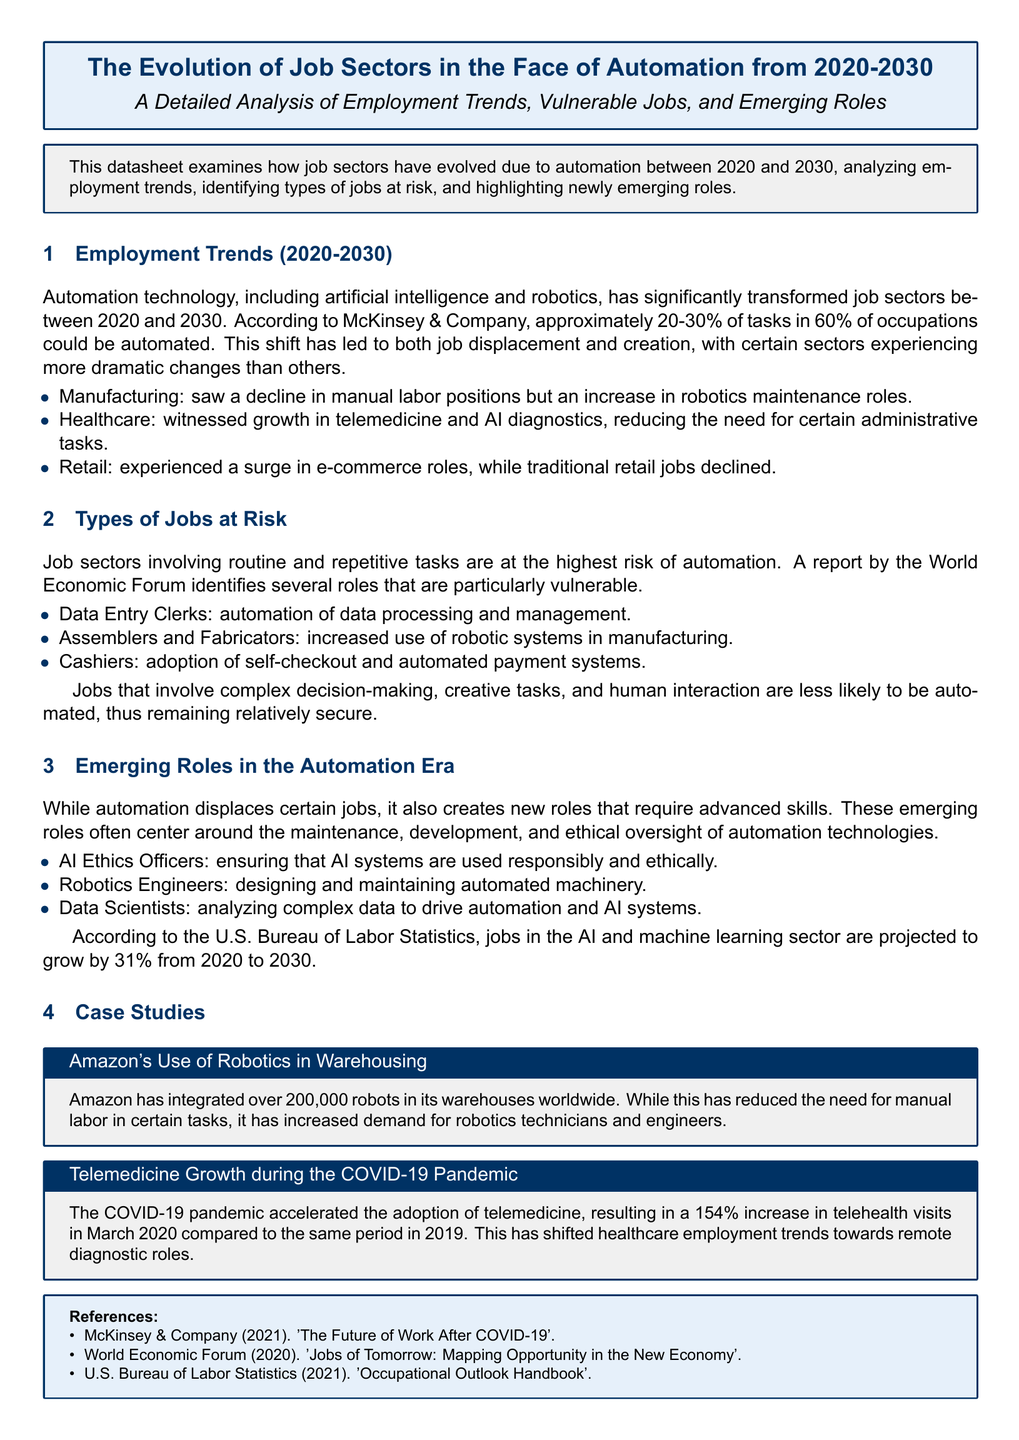What percentage of tasks in 60% of occupations could be automated? The document states that approximately 20-30% of tasks in 60% of occupations could be automated.
Answer: 20-30% Which job sector witnessed growth in telemedicine? The document mentions that the healthcare sector witnessed growth in telemedicine and AI diagnostics.
Answer: Healthcare What role has seen a decline due to the automation of payment systems? The document identifies cashiers as a role that has seen a decline due to automated payment systems.
Answer: Cashiers What is projected to grow by 31% from 2020 to 2030? The document states that jobs in the AI and machine learning sector are projected to grow by 31% from 2020 to 2030.
Answer: AI and machine learning sector How many robots has Amazon integrated into its warehouses? According to the document, Amazon has integrated over 200,000 robots in its warehouses worldwide.
Answer: 200,000 Which role is responsible for ensuring AI systems are used ethically? The document mentions AI Ethics Officers as the role responsible for ensuring ethical use of AI systems.
Answer: AI Ethics Officers Which event accelerated the adoption of telemedicine? The document indicates that the COVID-19 pandemic accelerated the adoption of telemedicine.
Answer: COVID-19 pandemic What type of jobs are less likely to be automated? The document describes jobs that involve complex decision-making, creative tasks, and human interaction as less likely to be automated.
Answer: Complex decision-making, creative tasks, and human interaction 